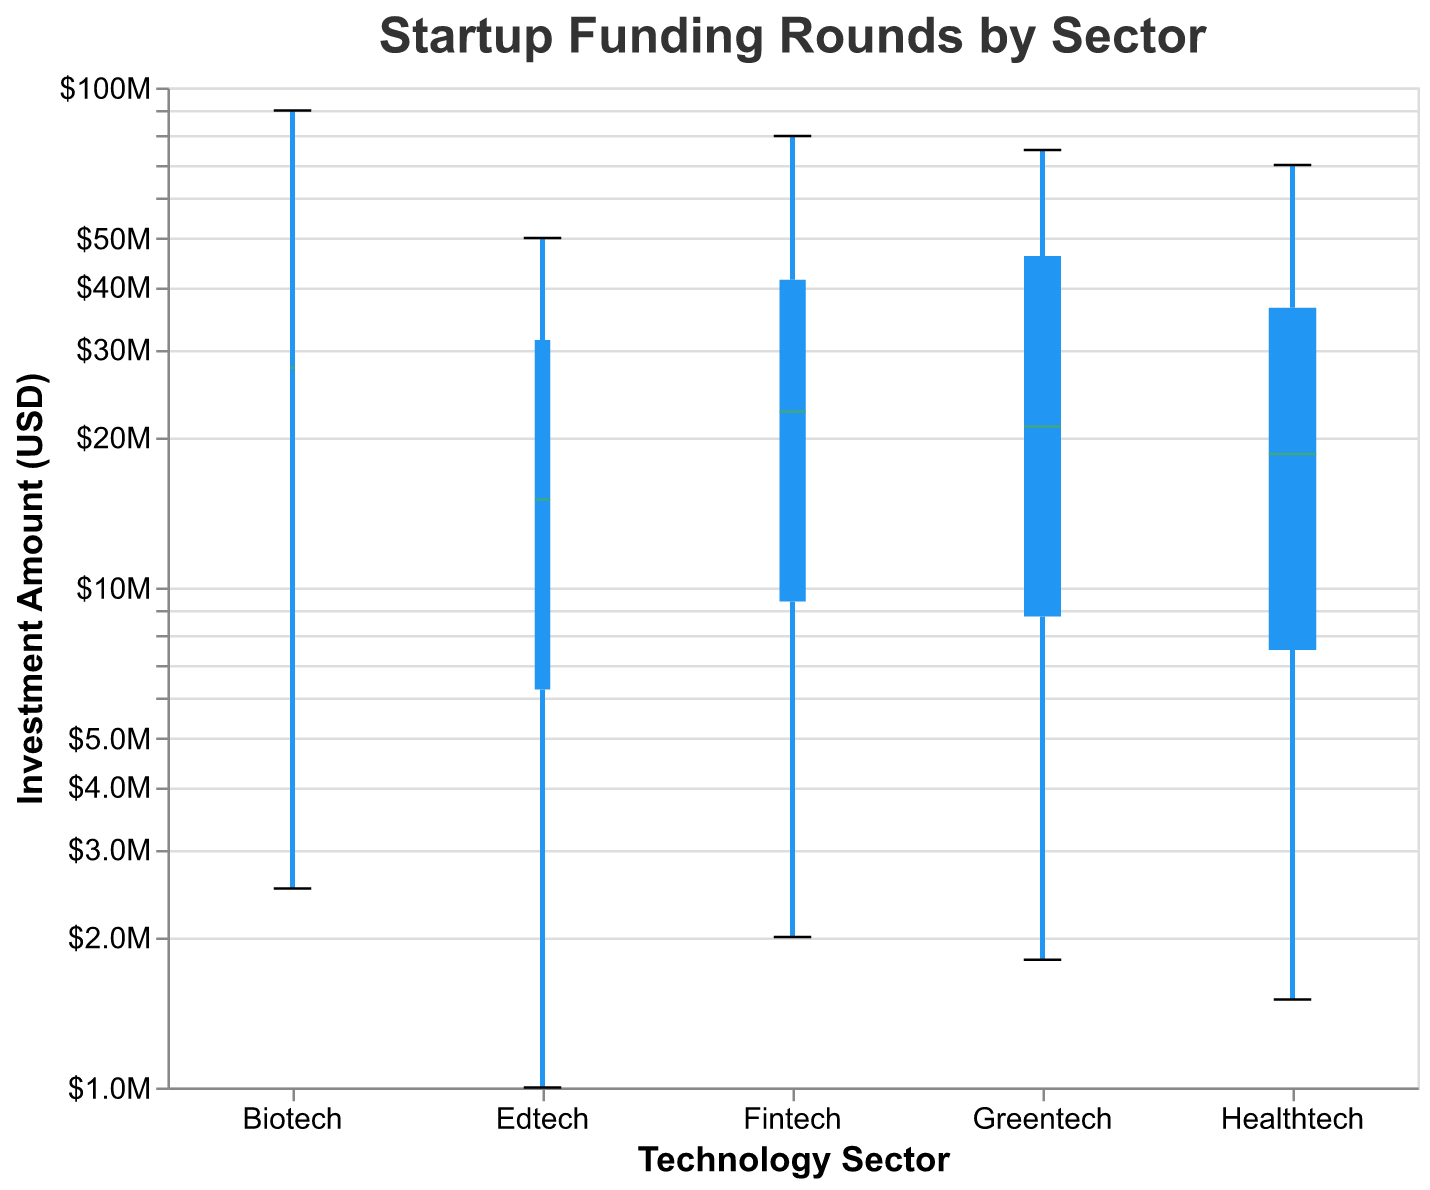Which sector has the largest average investment amount? The sector with the largest average investment amount can be determined by observing the upper bound of the investment amount in each box plot. The sector with the highest upper bound is Biotech.
Answer: Biotech What’s the investment amount for Fintech in Series E? The tooltip indicates that Fintech received $80,000,000 in Series E. This information can be found by hovering over the relevant part of the box plot.
Answer: $80,000,000 Which technology sector has the smallest investment amount? And how much is it? The smallest investment amount can be determined by looking at the bottommost point of each box plot. According to the figure, Edtech has the smallest investment amount at $1,000,000.
Answer: Edtech, $1,000,000 What is the median investment amount for Healthtech? The median investment amount is represented by the green line within the Healthtech box plot. This median value for Healthtech is approximately $12,000,000.
Answer: $12,000,000 Are there more variations in investment amounts in Biotech compared to Greentech? By comparing the interquartile ranges and the overall ranges (shorter boxes and whiskers in the box plot), we see greater variations in Biotech investment amounts since Biotech’s box whiskers span a wider range.
Answer: Yes Comparing the medians, which sector has the highest median investment amount? The highest median investment amount is represented by the green line in the box plot. Biotech has the highest median value as compared to other sectors.
Answer: Biotech What percentage increase is there from Seed funding to Series E funding in Edtech? Series E funding for Edtech is $50,000,000 and Seed funding is $1,000,000. The percentage increase is calculated by [(50,000,000 - 1,000,000) / 1,000,000] * 100 = 4900%.
Answer: 4900% What is the interquartile range of investment amounts for Fintech? The interquartile range (IQR) is the difference between the 75th percentile and 25th percentile. For Fintech, the lower quartile is around $7,500,000, and the upper quartile is about $45,000,000; therefore, IQR = $45,000,000 - $7,500,000 = $37,500,000.
Answer: $37,500,000 